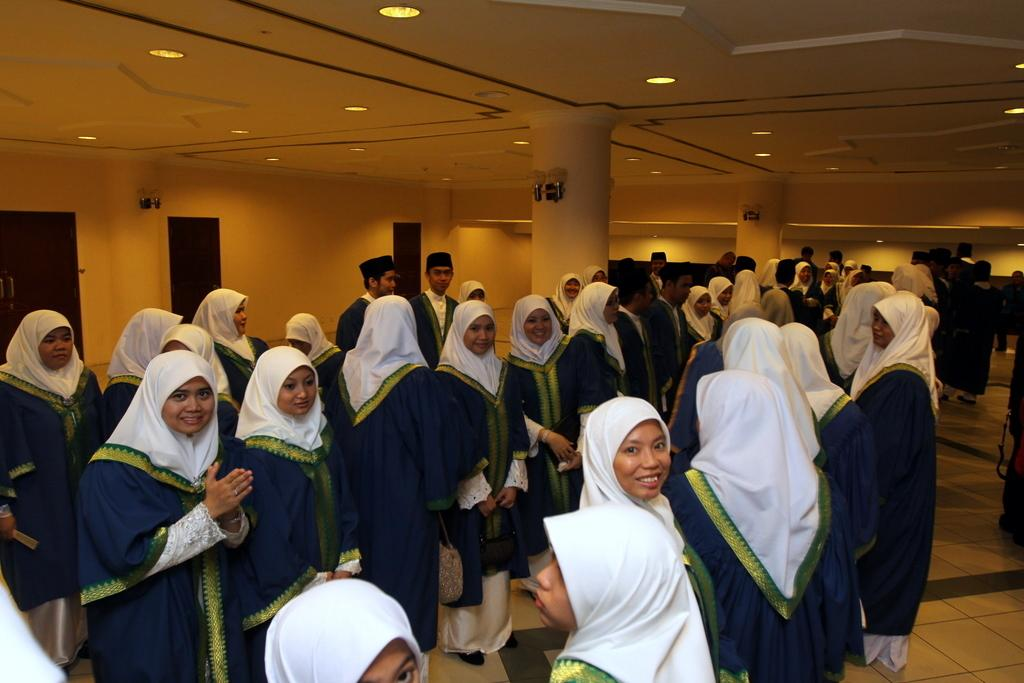How many people are in the image? There are people in the image, but the exact number is not specified. What are some people wearing in the image? Some people are wearing caps in the image. What can be seen at the top of the image? There are lights visible at the top of the image. What type of structure is present in the image? There is a roof and pillars in the image, suggesting a building or enclosed space. What is visible at the bottom of the image? There is a floor visible at the bottom of the image. Can you tell me how many apples are on the table in the image? There is no mention of apples or a table in the image, so it is not possible to answer that question. 